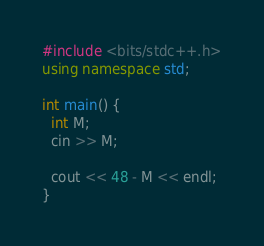<code> <loc_0><loc_0><loc_500><loc_500><_C++_>#include <bits/stdc++.h>
using namespace std;

int main() {
  int M;
  cin >> M;
  
  cout << 48 - M << endl;
}</code> 